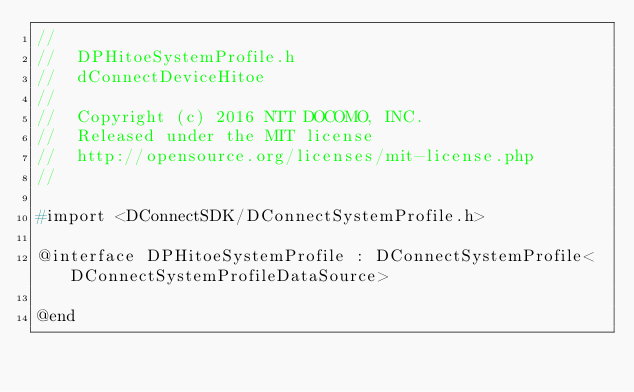<code> <loc_0><loc_0><loc_500><loc_500><_C_>//
//  DPHitoeSystemProfile.h
//  dConnectDeviceHitoe
//
//  Copyright (c) 2016 NTT DOCOMO, INC.
//  Released under the MIT license
//  http://opensource.org/licenses/mit-license.php
//

#import <DConnectSDK/DConnectSystemProfile.h>

@interface DPHitoeSystemProfile : DConnectSystemProfile<DConnectSystemProfileDataSource>

@end
</code> 